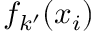<formula> <loc_0><loc_0><loc_500><loc_500>f _ { k ^ { \prime } } ( x _ { i } )</formula> 